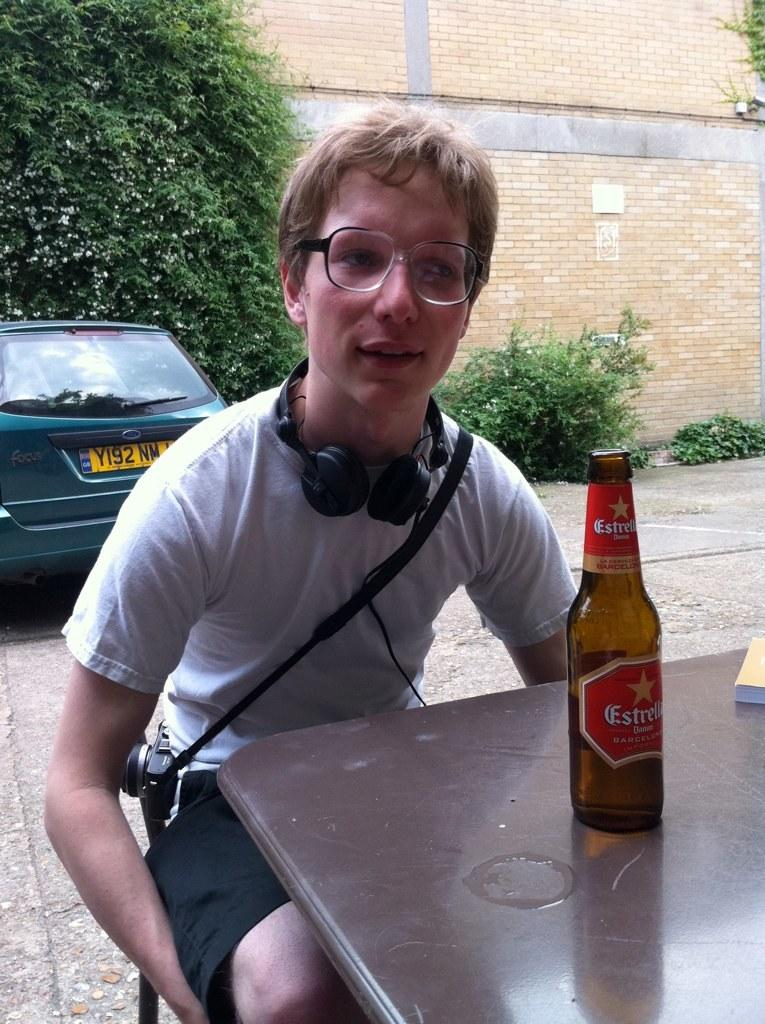What is the person in the image doing? The person is sitting on a chair in the image. What can be seen on the table in the image? There is a wine bottle on a table in the image. What is visible behind the person in the image? There is a car visible behind the person. Can you describe the zephyr blowing through the person's hair in the image? There is no zephyr or wind blowing through the person's hair in the image. How does the person's breath affect the wine bottle in the image? The person's breath does not affect the wine bottle in the image, as there is no interaction between the person and the wine bottle. 